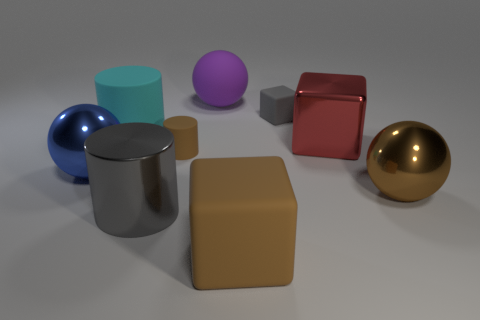Add 1 big brown blocks. How many objects exist? 10 Subtract all cubes. How many objects are left? 6 Add 3 tiny gray matte things. How many tiny gray matte things are left? 4 Add 5 cubes. How many cubes exist? 8 Subtract 0 green spheres. How many objects are left? 9 Subtract all large red cubes. Subtract all small gray things. How many objects are left? 7 